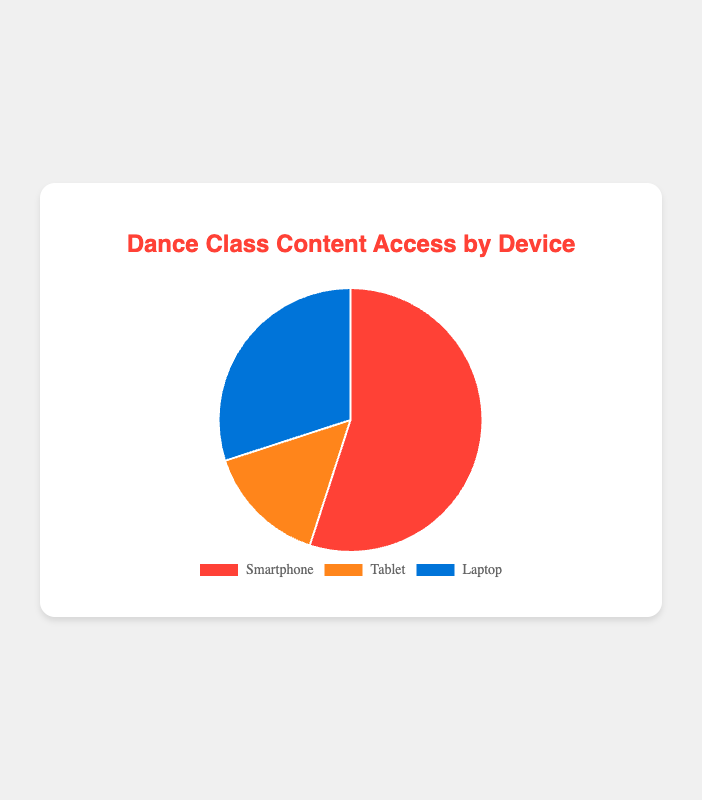What is the most commonly used device to access the online dance class content? The pie chart shows the percentage distribution of devices used to access the online dance class content. The device with the highest percentage is the most commonly used.
Answer: Smartphone What is the total percentage of followers using either a Tablet or a Laptop? To find the total percentage, add the percentages for Tablet and Laptop. According to the pie chart, Tablet is 15% and Laptop is 30%. So, 15% + 30% = 45%.
Answer: 45% Which device has the second highest usage percentage? The pie chart shows the percentages for Smartphone, Tablet, and Laptop. The Smartphone has the highest at 55%, followed by the Laptop at 30%, and the Tablet at 15%. Therefore, the Laptop has the second highest usage.
Answer: Laptop How much more popular is the Smartphone compared to the Tablet? The pie chart shows the percentage of usage for each device. The Smartphone is used by 55% of followers, while the Tablet is used by 15%. To find how much more popular the Smartphone is, subtract the percentage for the Tablet from the percentage for the Smartphone: 55% - 15% = 40%.
Answer: 40% If the total number of followers is 2000, how many access the content via Laptop? First, find the percentage of followers using a Laptop from the pie chart, which is 30%. To find the number of followers, calculate 30% of 2000: (30/100) * 2000 = 600 followers.
Answer: 600 What is the combined percentage of followers using Smartphone and Laptop? To find the combined percentage, add the percentages for Smartphone and Laptop. According to the pie chart, Smartphone is 55% and Laptop is 30%. So, 55% + 30% = 85%.
Answer: 85% Which device is least used by followers to access the online dance class content? The pie chart shows the percentages for Smartphone, Tablet, and Laptop. The device with the lowest percentage is considered the least used. From the chart, the Tablet has the smallest percentage at 15%.
Answer: Tablet How much less is the percentage of Laptop usage compared to that of Smartphone usage? The pie chart shows that the Smartphone is used by 55% of followers and the Laptop by 30%. To find the difference, subtract the Laptop percentage from the Smartphone percentage: 55% - 30% = 25%.
Answer: 25% 